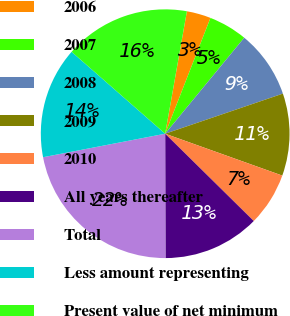<chart> <loc_0><loc_0><loc_500><loc_500><pie_chart><fcel>2006<fcel>2007<fcel>2008<fcel>2009<fcel>2010<fcel>All years thereafter<fcel>Total<fcel>Less amount representing<fcel>Present value of net minimum<nl><fcel>3.14%<fcel>5.03%<fcel>8.81%<fcel>10.69%<fcel>6.92%<fcel>12.58%<fcel>22.01%<fcel>14.47%<fcel>16.35%<nl></chart> 